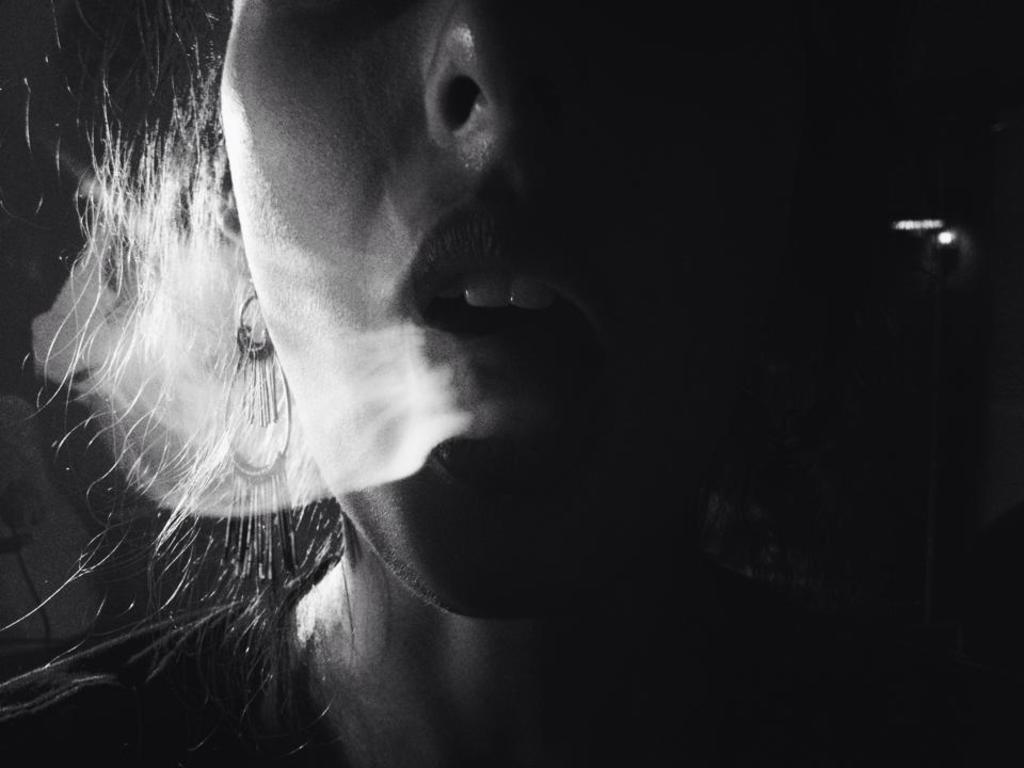Who is present in the image? There is a woman in the image. What is the color scheme of the image? The image is black and white. What can be seen in the image besides the woman? There is smoke visible in the image. What type of crayon is the woman using to draw in the image? There is no crayon present in the image, and the woman is not drawing. 